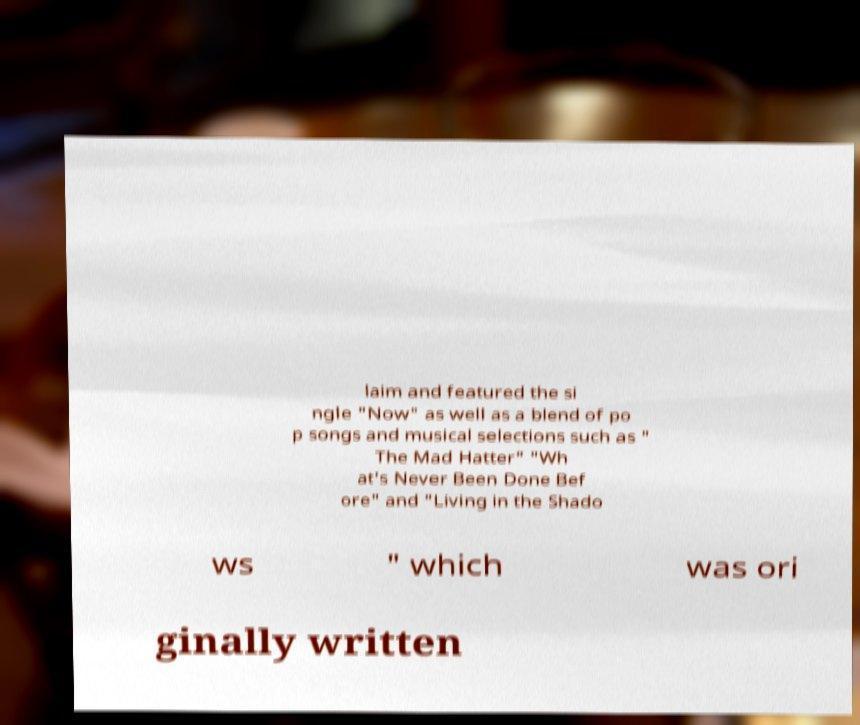Can you accurately transcribe the text from the provided image for me? laim and featured the si ngle "Now" as well as a blend of po p songs and musical selections such as " The Mad Hatter" "Wh at's Never Been Done Bef ore" and "Living in the Shado ws " which was ori ginally written 